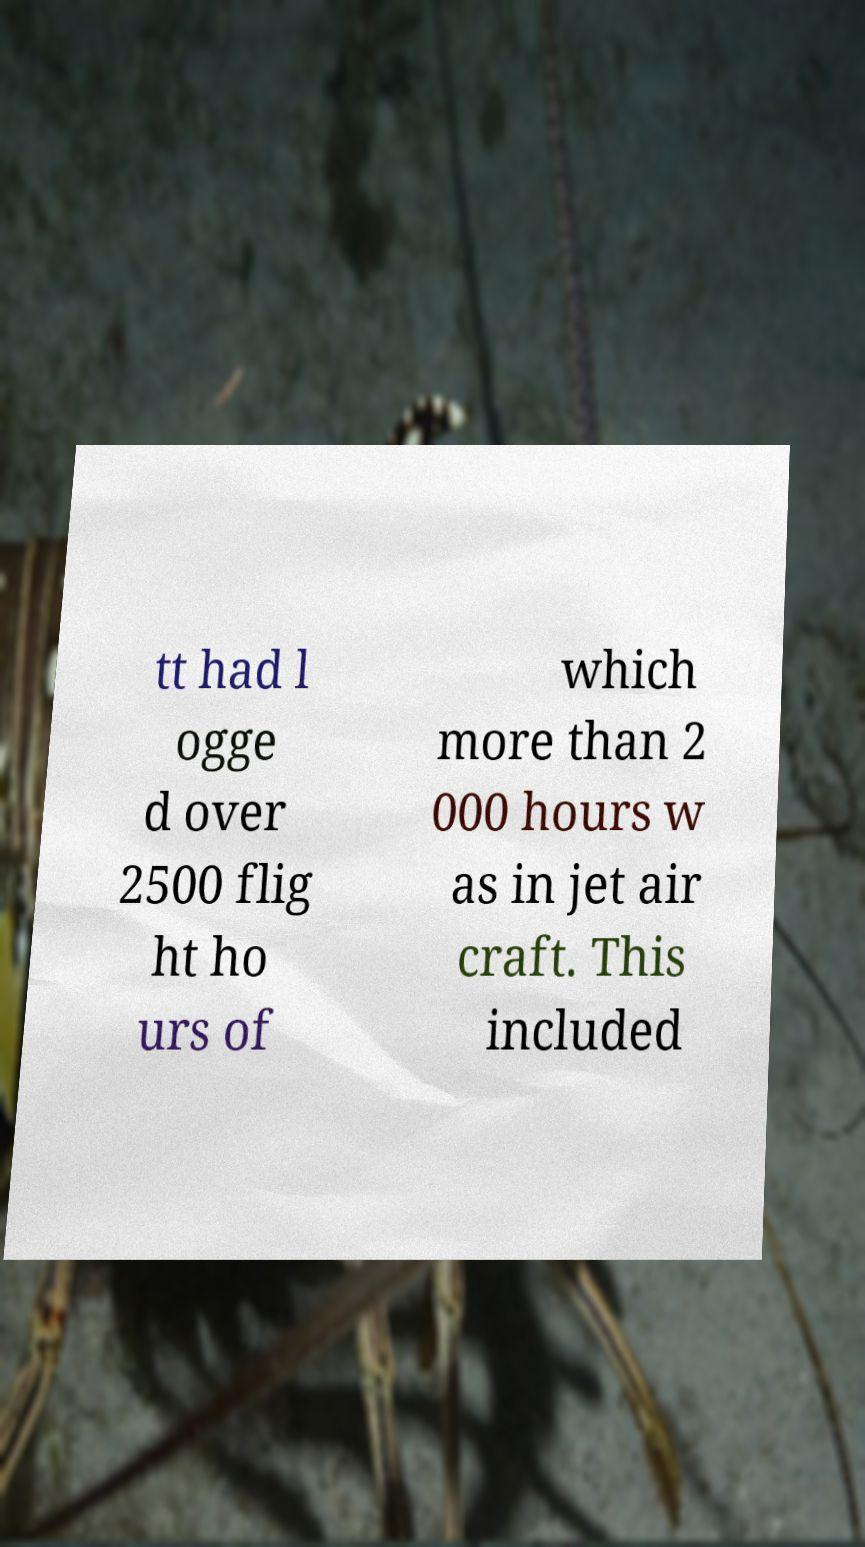Could you assist in decoding the text presented in this image and type it out clearly? tt had l ogge d over 2500 flig ht ho urs of which more than 2 000 hours w as in jet air craft. This included 